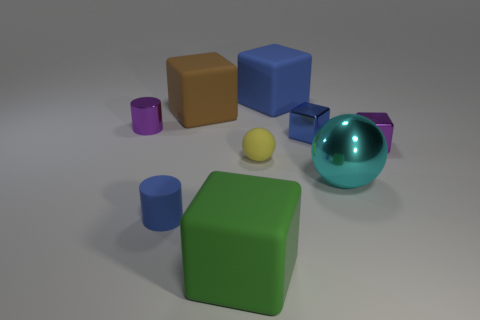Subtract all small metallic cubes. How many cubes are left? 3 Subtract all cyan balls. How many balls are left? 1 Add 1 small cyan things. How many objects exist? 10 Subtract 2 balls. How many balls are left? 0 Subtract all brown balls. Subtract all brown blocks. How many balls are left? 2 Subtract all red blocks. How many gray cylinders are left? 0 Subtract all large objects. Subtract all small yellow rubber spheres. How many objects are left? 4 Add 8 tiny cylinders. How many tiny cylinders are left? 10 Add 4 cyan metallic spheres. How many cyan metallic spheres exist? 5 Subtract 0 green cylinders. How many objects are left? 9 